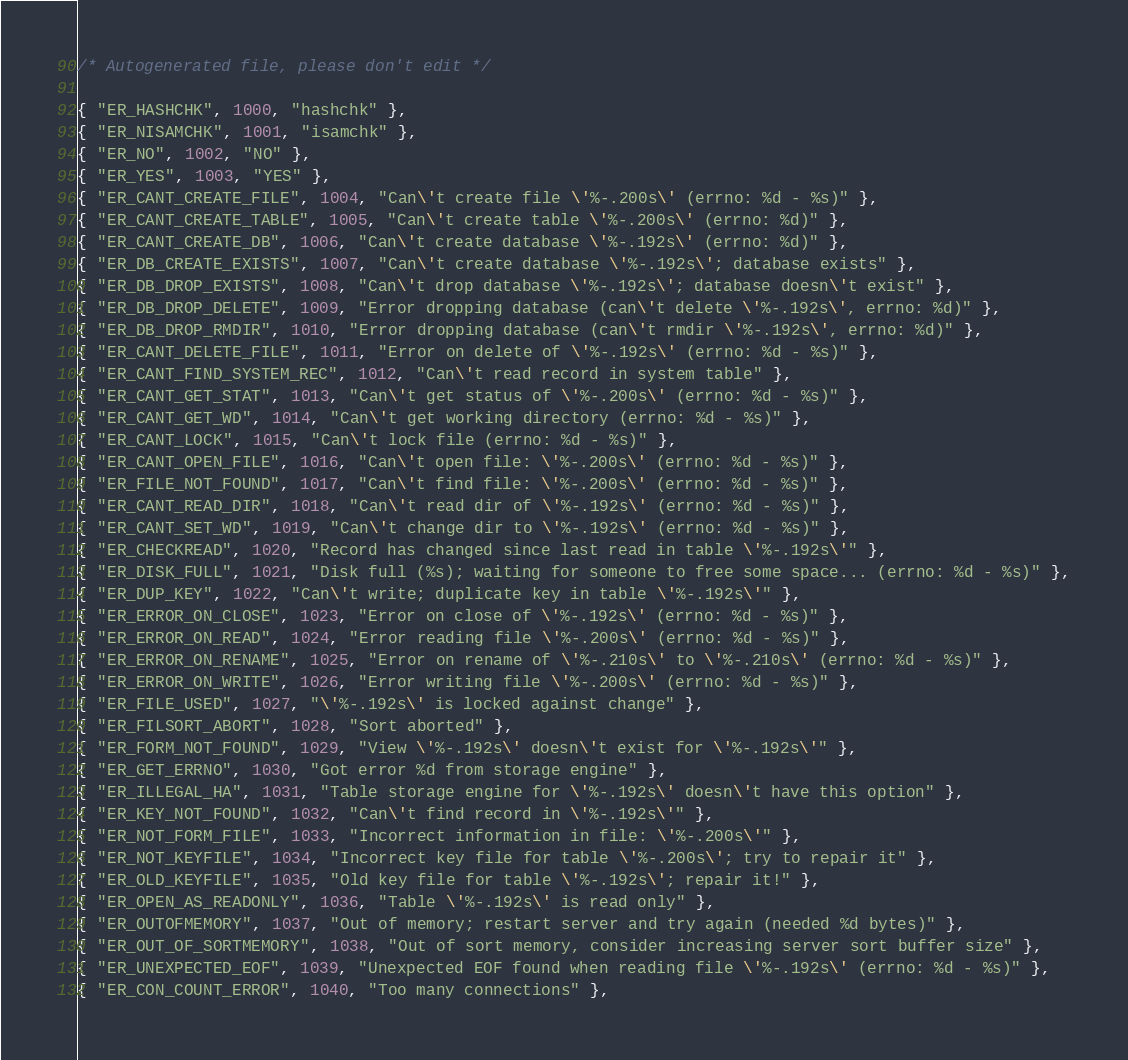Convert code to text. <code><loc_0><loc_0><loc_500><loc_500><_C_>/* Autogenerated file, please don't edit */

{ "ER_HASHCHK", 1000, "hashchk" },
{ "ER_NISAMCHK", 1001, "isamchk" },
{ "ER_NO", 1002, "NO" },
{ "ER_YES", 1003, "YES" },
{ "ER_CANT_CREATE_FILE", 1004, "Can\'t create file \'%-.200s\' (errno: %d - %s)" },
{ "ER_CANT_CREATE_TABLE", 1005, "Can\'t create table \'%-.200s\' (errno: %d)" },
{ "ER_CANT_CREATE_DB", 1006, "Can\'t create database \'%-.192s\' (errno: %d)" },
{ "ER_DB_CREATE_EXISTS", 1007, "Can\'t create database \'%-.192s\'; database exists" },
{ "ER_DB_DROP_EXISTS", 1008, "Can\'t drop database \'%-.192s\'; database doesn\'t exist" },
{ "ER_DB_DROP_DELETE", 1009, "Error dropping database (can\'t delete \'%-.192s\', errno: %d)" },
{ "ER_DB_DROP_RMDIR", 1010, "Error dropping database (can\'t rmdir \'%-.192s\', errno: %d)" },
{ "ER_CANT_DELETE_FILE", 1011, "Error on delete of \'%-.192s\' (errno: %d - %s)" },
{ "ER_CANT_FIND_SYSTEM_REC", 1012, "Can\'t read record in system table" },
{ "ER_CANT_GET_STAT", 1013, "Can\'t get status of \'%-.200s\' (errno: %d - %s)" },
{ "ER_CANT_GET_WD", 1014, "Can\'t get working directory (errno: %d - %s)" },
{ "ER_CANT_LOCK", 1015, "Can\'t lock file (errno: %d - %s)" },
{ "ER_CANT_OPEN_FILE", 1016, "Can\'t open file: \'%-.200s\' (errno: %d - %s)" },
{ "ER_FILE_NOT_FOUND", 1017, "Can\'t find file: \'%-.200s\' (errno: %d - %s)" },
{ "ER_CANT_READ_DIR", 1018, "Can\'t read dir of \'%-.192s\' (errno: %d - %s)" },
{ "ER_CANT_SET_WD", 1019, "Can\'t change dir to \'%-.192s\' (errno: %d - %s)" },
{ "ER_CHECKREAD", 1020, "Record has changed since last read in table \'%-.192s\'" },
{ "ER_DISK_FULL", 1021, "Disk full (%s); waiting for someone to free some space... (errno: %d - %s)" },
{ "ER_DUP_KEY", 1022, "Can\'t write; duplicate key in table \'%-.192s\'" },
{ "ER_ERROR_ON_CLOSE", 1023, "Error on close of \'%-.192s\' (errno: %d - %s)" },
{ "ER_ERROR_ON_READ", 1024, "Error reading file \'%-.200s\' (errno: %d - %s)" },
{ "ER_ERROR_ON_RENAME", 1025, "Error on rename of \'%-.210s\' to \'%-.210s\' (errno: %d - %s)" },
{ "ER_ERROR_ON_WRITE", 1026, "Error writing file \'%-.200s\' (errno: %d - %s)" },
{ "ER_FILE_USED", 1027, "\'%-.192s\' is locked against change" },
{ "ER_FILSORT_ABORT", 1028, "Sort aborted" },
{ "ER_FORM_NOT_FOUND", 1029, "View \'%-.192s\' doesn\'t exist for \'%-.192s\'" },
{ "ER_GET_ERRNO", 1030, "Got error %d from storage engine" },
{ "ER_ILLEGAL_HA", 1031, "Table storage engine for \'%-.192s\' doesn\'t have this option" },
{ "ER_KEY_NOT_FOUND", 1032, "Can\'t find record in \'%-.192s\'" },
{ "ER_NOT_FORM_FILE", 1033, "Incorrect information in file: \'%-.200s\'" },
{ "ER_NOT_KEYFILE", 1034, "Incorrect key file for table \'%-.200s\'; try to repair it" },
{ "ER_OLD_KEYFILE", 1035, "Old key file for table \'%-.192s\'; repair it!" },
{ "ER_OPEN_AS_READONLY", 1036, "Table \'%-.192s\' is read only" },
{ "ER_OUTOFMEMORY", 1037, "Out of memory; restart server and try again (needed %d bytes)" },
{ "ER_OUT_OF_SORTMEMORY", 1038, "Out of sort memory, consider increasing server sort buffer size" },
{ "ER_UNEXPECTED_EOF", 1039, "Unexpected EOF found when reading file \'%-.192s\' (errno: %d - %s)" },
{ "ER_CON_COUNT_ERROR", 1040, "Too many connections" },</code> 